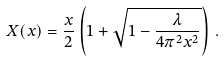<formula> <loc_0><loc_0><loc_500><loc_500>X ( x ) = \frac { x } 2 \left ( 1 + \sqrt { 1 - \frac { \lambda } { 4 \pi ^ { 2 } x ^ { 2 } } } \right ) \, .</formula> 